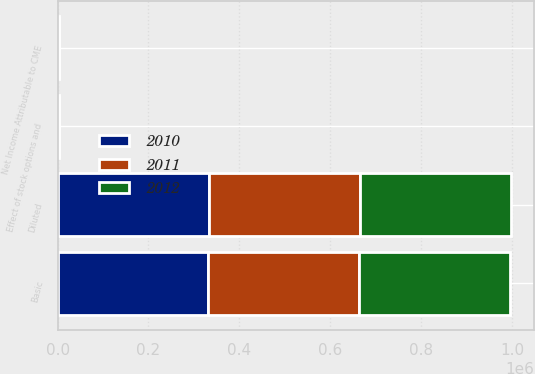Convert chart. <chart><loc_0><loc_0><loc_500><loc_500><stacked_bar_chart><ecel><fcel>Net Income Attributable to CME<fcel>Basic<fcel>Effect of stock options and<fcel>Diluted<nl><fcel>2012<fcel>896.3<fcel>331252<fcel>1067<fcel>332319<nl><fcel>2011<fcel>1812.3<fcel>332737<fcel>1074<fcel>333811<nl><fcel>2010<fcel>951.4<fcel>331493<fcel>982<fcel>332475<nl></chart> 